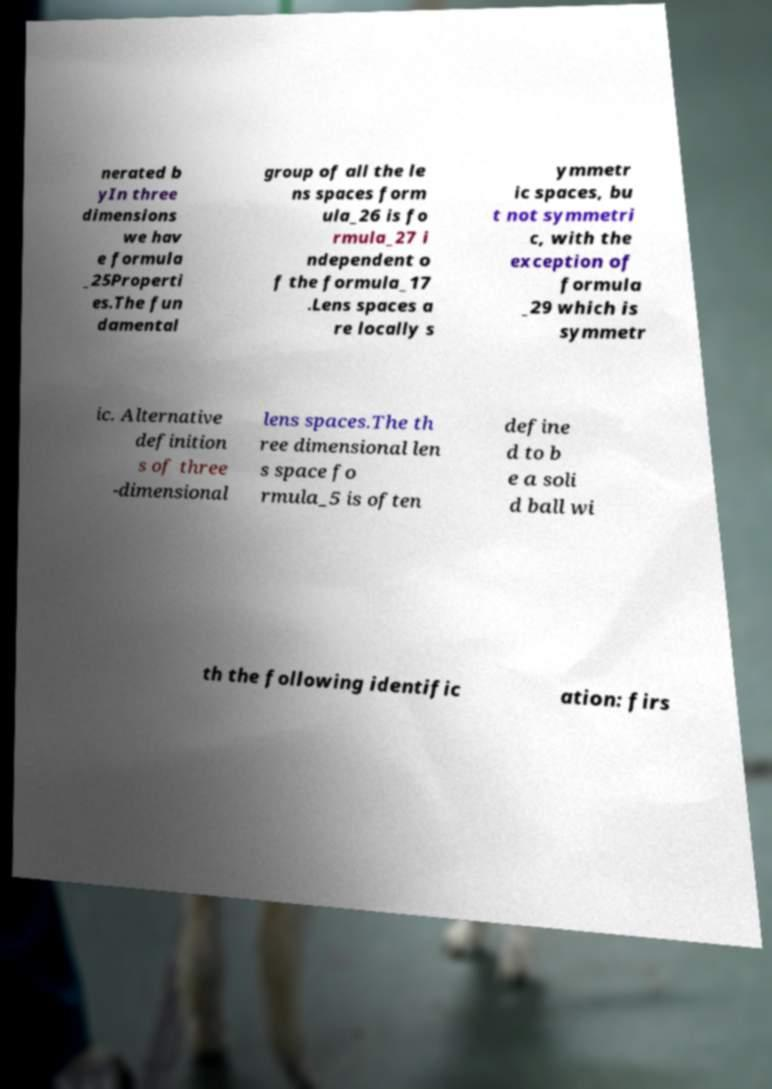Could you assist in decoding the text presented in this image and type it out clearly? nerated b yIn three dimensions we hav e formula _25Properti es.The fun damental group of all the le ns spaces form ula_26 is fo rmula_27 i ndependent o f the formula_17 .Lens spaces a re locally s ymmetr ic spaces, bu t not symmetri c, with the exception of formula _29 which is symmetr ic. Alternative definition s of three -dimensional lens spaces.The th ree dimensional len s space fo rmula_5 is often define d to b e a soli d ball wi th the following identific ation: firs 